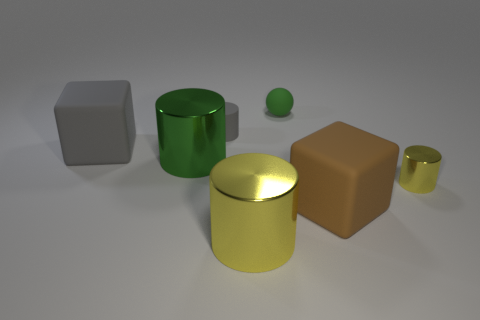Subtract all tiny yellow cylinders. How many cylinders are left? 3 Add 3 brown rubber objects. How many objects exist? 10 Subtract all green cylinders. How many cylinders are left? 3 Subtract all balls. How many objects are left? 6 Subtract all green spheres. How many yellow cylinders are left? 2 Add 5 tiny yellow cylinders. How many tiny yellow cylinders exist? 6 Subtract 0 blue spheres. How many objects are left? 7 Subtract 1 blocks. How many blocks are left? 1 Subtract all yellow cylinders. Subtract all cyan blocks. How many cylinders are left? 2 Subtract all brown matte things. Subtract all matte cylinders. How many objects are left? 5 